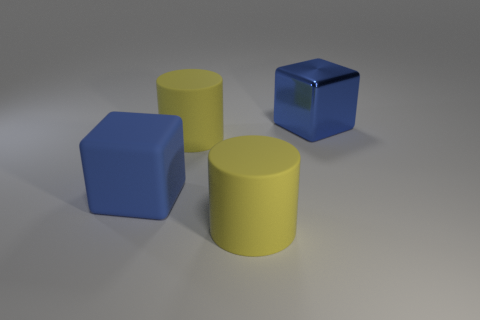Subtract 1 cylinders. How many cylinders are left? 1 Subtract all yellow balls. How many purple cylinders are left? 0 Subtract all large rubber cylinders. Subtract all blue shiny things. How many objects are left? 1 Add 2 big cubes. How many big cubes are left? 4 Add 2 large yellow things. How many large yellow things exist? 4 Add 2 large yellow cubes. How many objects exist? 6 Subtract 0 brown cubes. How many objects are left? 4 Subtract all green cylinders. Subtract all brown balls. How many cylinders are left? 2 